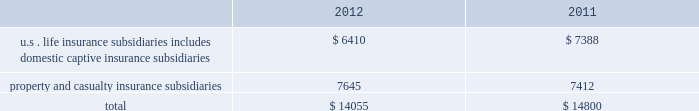Table of contents statutory surplus the table below sets forth statutory surplus for the company 2019s insurance companies as of december 31 , 2012 and 2011: .
Statutory capital and surplus for the u.s .
Life insurance subsidiaries , including domestic captive insurance subsidiaries , decreased by $ 978 , primarily due to variable annuity surplus impacts of approximately $ 425 , a $ 200 increase in reserves on a change in valuation basis , $ 200 transfer of the mutual funds business from the u.s .
Life insurance companies to the life holding company , and an increase in the asset valuation reserve of $ 115 .
As a result of the january 2013 statutory gain from the sale of the retirement plans and individual life businesses , the company's pro forma january 2 , 2013 u.s .
Life statutory surplus was estimated to be $ 8.1 billion , before approximately $ 1.5 billion in extraordinary dividends and return of capital to hfsg holding company .
Statutory capital and surplus for the property and casualty insurance subsidiaries increased by $ 233 , primarily due to statutory net income , after tax , of $ 727 , unrealized gains of $ 249 , and an increase in statutory admitted deferred tax assets of $ 77 , capital contributions of $ 14 , and an increase of statutory admitted assets of $ 7 , partially offset by dividends to the hfsg holding company of $ 841 .
Both net income and dividends are net of interest payments and dividends , respectively , on an intercompany note between hartford holdings , inc .
And hartford fire insurance company .
The company also holds regulatory capital and surplus for its operations in japan .
Under the accounting practices and procedures governed by japanese regulatory authorities , the company 2019s statutory capital and surplus was $ 1.1 billion and $ 1.3 billion as of december 31 , 2012 and 2011 , respectively .
Statutory capital the company 2019s stockholders 2019 equity , as prepared using u.s .
Generally accepted accounting principles ( 201cu.s .
Gaap 201d ) was $ 22.4 billion as of december 31 , 2012 .
The company 2019s estimated aggregate statutory capital and surplus , as prepared in accordance with the national association of insurance commissioners 2019 accounting practices and procedures manual ( 201cu.s .
Stat 201d ) was $ 14.1 billion as of december 31 , 2012 .
Significant differences between u.s .
Gaap stockholders 2019 equity and aggregate statutory capital and surplus prepared in accordance with u.s .
Stat include the following : 2022 u.s .
Stat excludes equity of non-insurance and foreign insurance subsidiaries not held by u.s .
Insurance subsidiaries .
2022 costs incurred by the company to acquire insurance policies are deferred under u.s .
Gaap while those costs are expensed immediately under u.s .
2022 temporary differences between the book and tax basis of an asset or liability which are recorded as deferred tax assets are evaluated for recoverability under u.s .
Gaap while those amounts deferred are subject to limitations under u.s .
Stat .
2022 the assumptions used in the determination of life benefit reserves is prescribed under u.s .
Stat , while the assumptions used under u.s .
Gaap are generally the company 2019s best estimates .
The methodologies for determining life insurance reserve amounts may also be different .
For example , reserving for living benefit reserves under u.s .
Stat is generally addressed by the commissioners 2019 annuity reserving valuation methodology and the related actuarial guidelines , while under u.s .
Gaap , those same living benefits may be considered embedded derivatives and recorded at fair value or they may be considered sop 03-1 reserves .
The sensitivity of these life insurance reserves to changes in equity markets , as applicable , will be different between u.s .
Gaap and u.s .
Stat .
2022 the difference between the amortized cost and fair value of fixed maturity and other investments , net of tax , is recorded as an increase or decrease to the carrying value of the related asset and to equity under u.s .
Gaap , while u.s .
Stat only records certain securities at fair value , such as equity securities and certain lower rated bonds required by the naic to be recorded at the lower of amortized cost or fair value .
2022 u.s .
Stat for life insurance companies establishes a formula reserve for realized and unrealized losses due to default and equity risks associated with certain invested assets ( the asset valuation reserve ) , while u.s .
Gaap does not .
Also , for those realized gains and losses caused by changes in interest rates , u.s .
Stat for life insurance companies defers and amortizes the gains and losses , caused by changes in interest rates , into income over the original life to maturity of the asset sold ( the interest maintenance reserve ) while u.s .
Gaap does not .
2022 goodwill arising from the acquisition of a business is tested for recoverability on an annual basis ( or more frequently , as necessary ) for u.s .
Gaap , while under u.s .
Stat goodwill is amortized over a period not to exceed 10 years and the amount of goodwill is limited. .
As of december 312012 what was the percent of the total statutory surplus for the company 2019s insurance companies property and casualty insurance subsidiaries? 
Computations: (7645 / 14055)
Answer: 0.54393. 